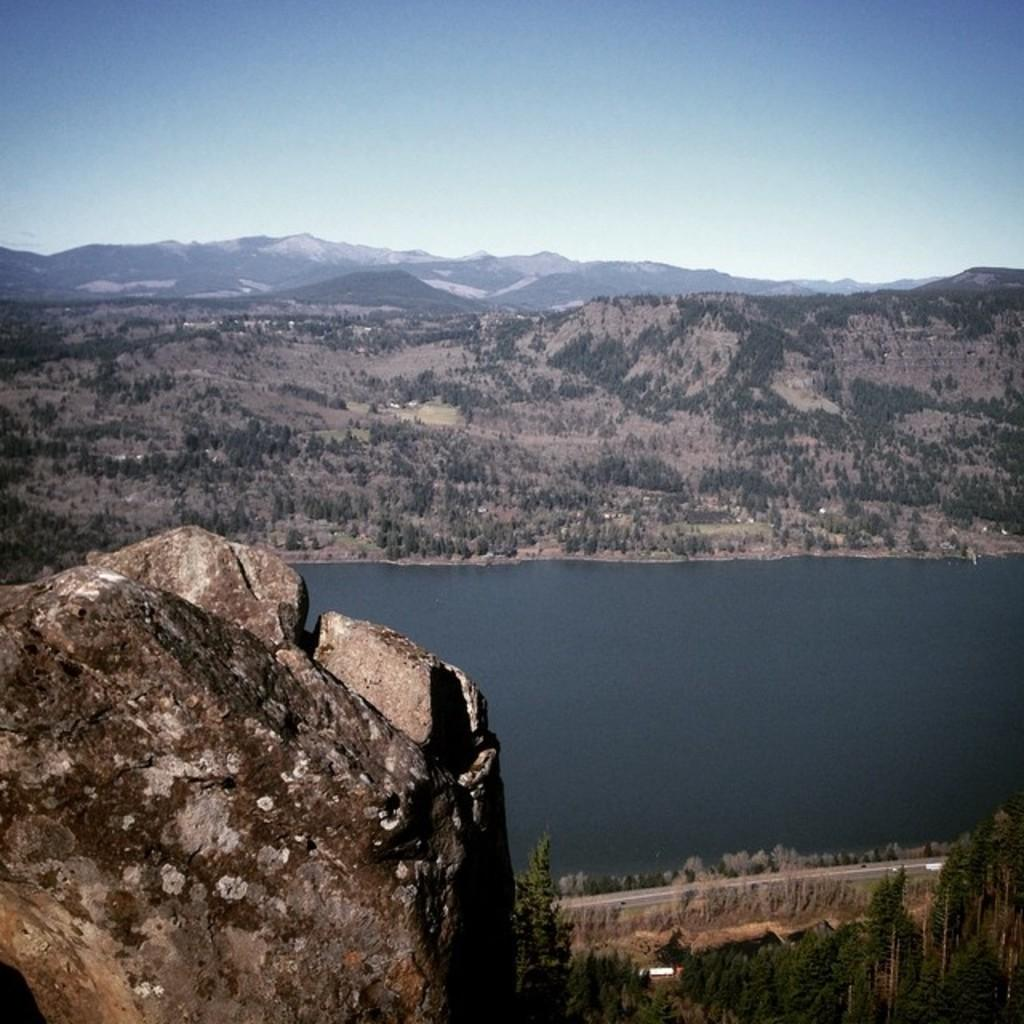What type of landform can be seen in the image? There is a hill in the image. What natural feature is visible in the image? There is water visible in the image. What type of terrain is in the background of the image? There are mountains in the image. What type of vegetation is present on the mountains? Trees and plants are present on the mountains. What day of the week is the minister asking a question in the image? There is no minister or question present in the image. 